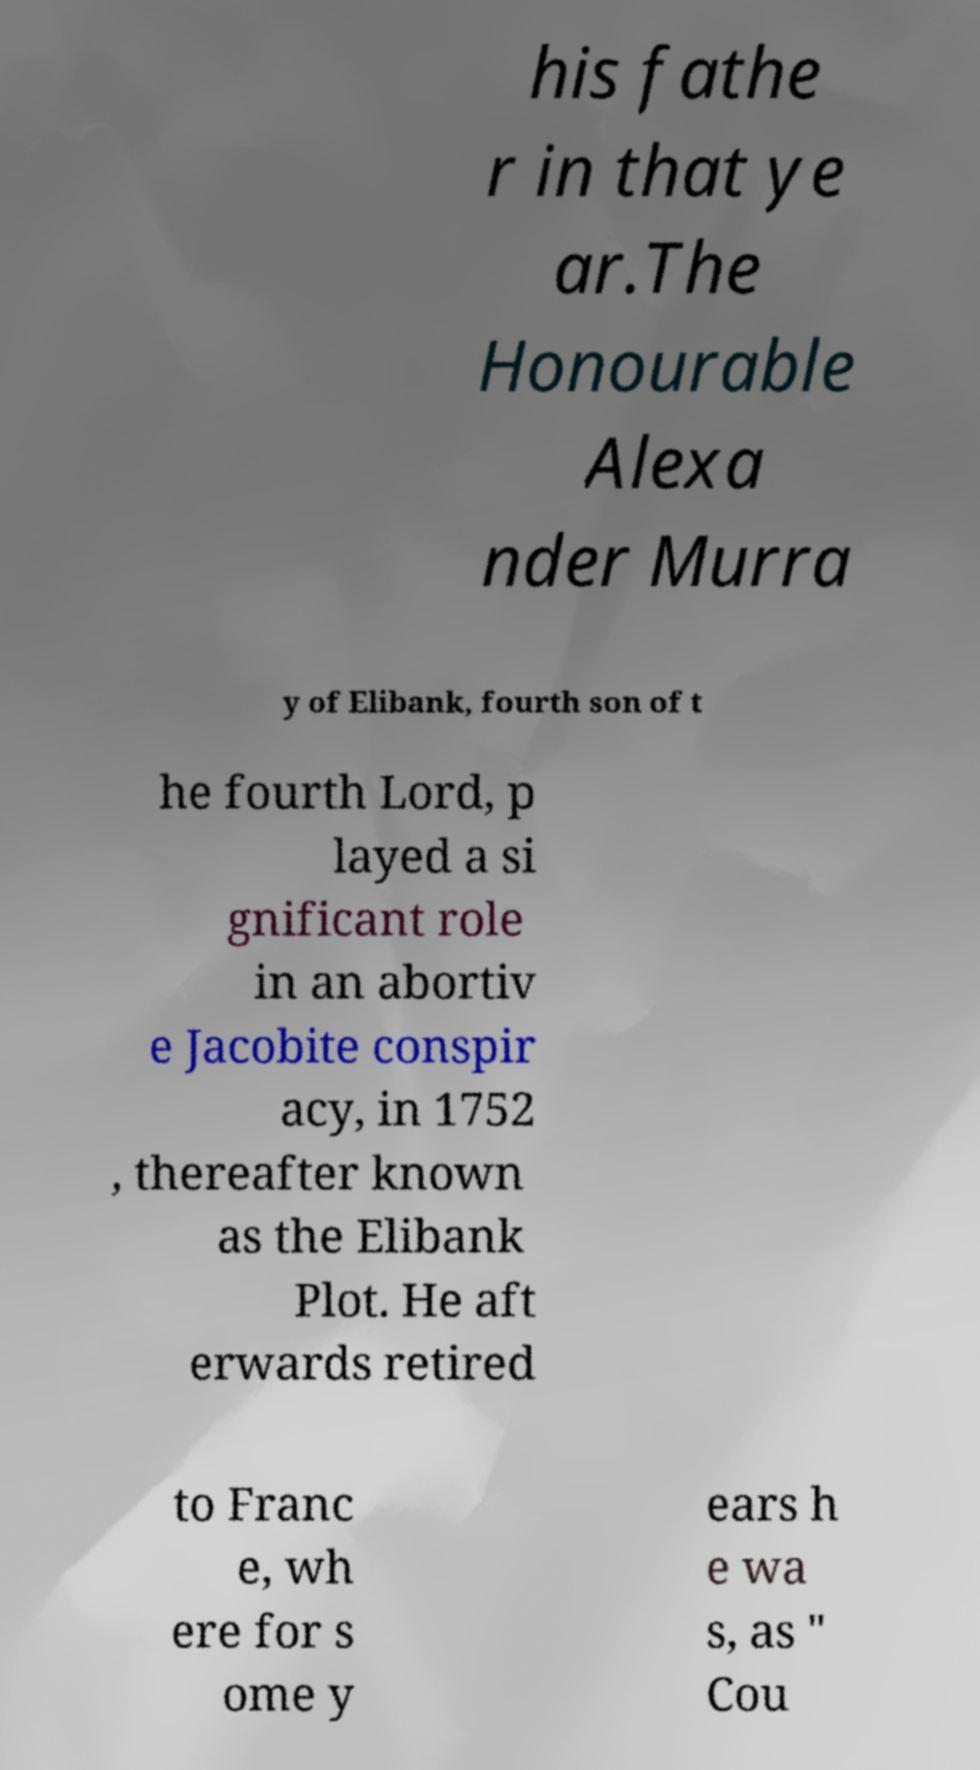Can you read and provide the text displayed in the image?This photo seems to have some interesting text. Can you extract and type it out for me? his fathe r in that ye ar.The Honourable Alexa nder Murra y of Elibank, fourth son of t he fourth Lord, p layed a si gnificant role in an abortiv e Jacobite conspir acy, in 1752 , thereafter known as the Elibank Plot. He aft erwards retired to Franc e, wh ere for s ome y ears h e wa s, as " Cou 